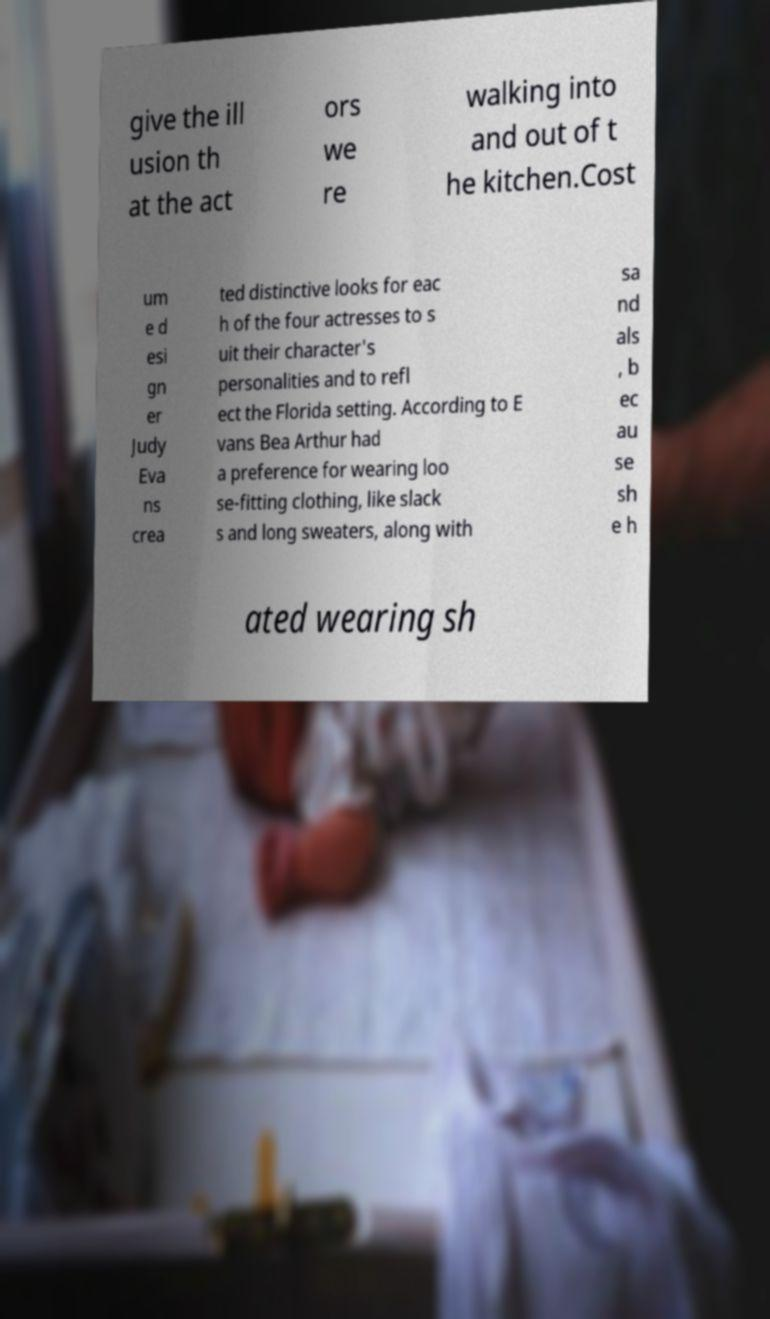For documentation purposes, I need the text within this image transcribed. Could you provide that? give the ill usion th at the act ors we re walking into and out of t he kitchen.Cost um e d esi gn er Judy Eva ns crea ted distinctive looks for eac h of the four actresses to s uit their character's personalities and to refl ect the Florida setting. According to E vans Bea Arthur had a preference for wearing loo se-fitting clothing, like slack s and long sweaters, along with sa nd als , b ec au se sh e h ated wearing sh 